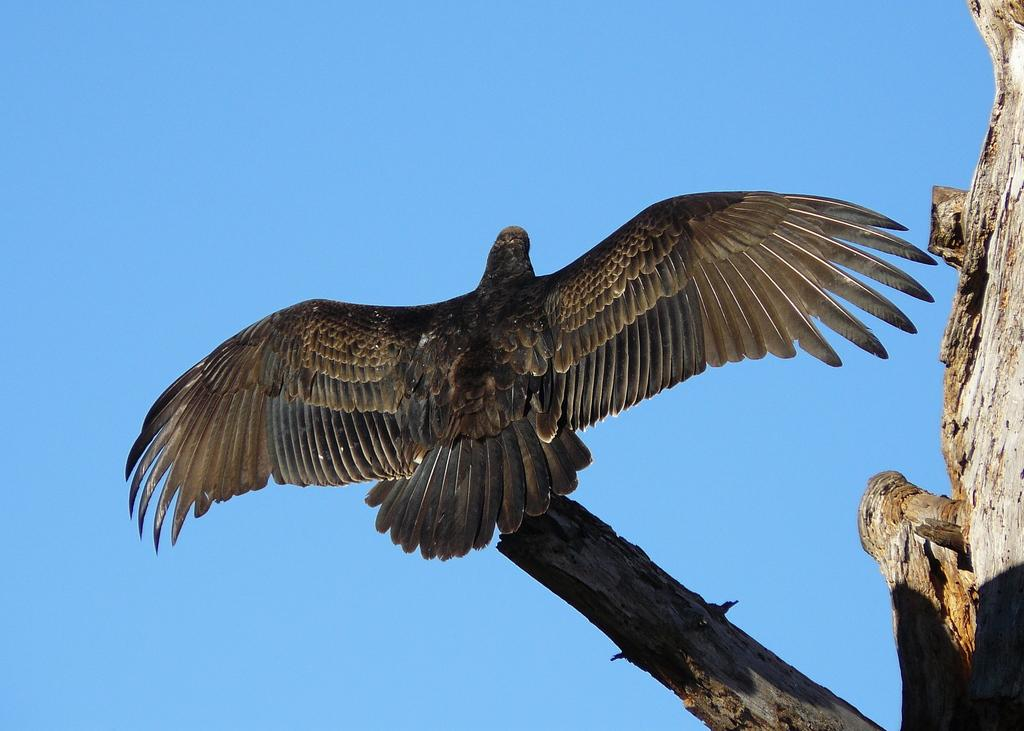What is the main subject in the foreground of the image? There is a bird in the foreground of the image. What is the bird perched on? The bird is on a wooden pole. What can be seen on the right side of the image? There is a wooden wall on the right side of the image. What is visible in the background of the image? The sky is visible in the background of the image. How does the bird transport itself to the unit in the image? There is no unit or transportation involved in the image; the bird is simply perched on a wooden pole. 